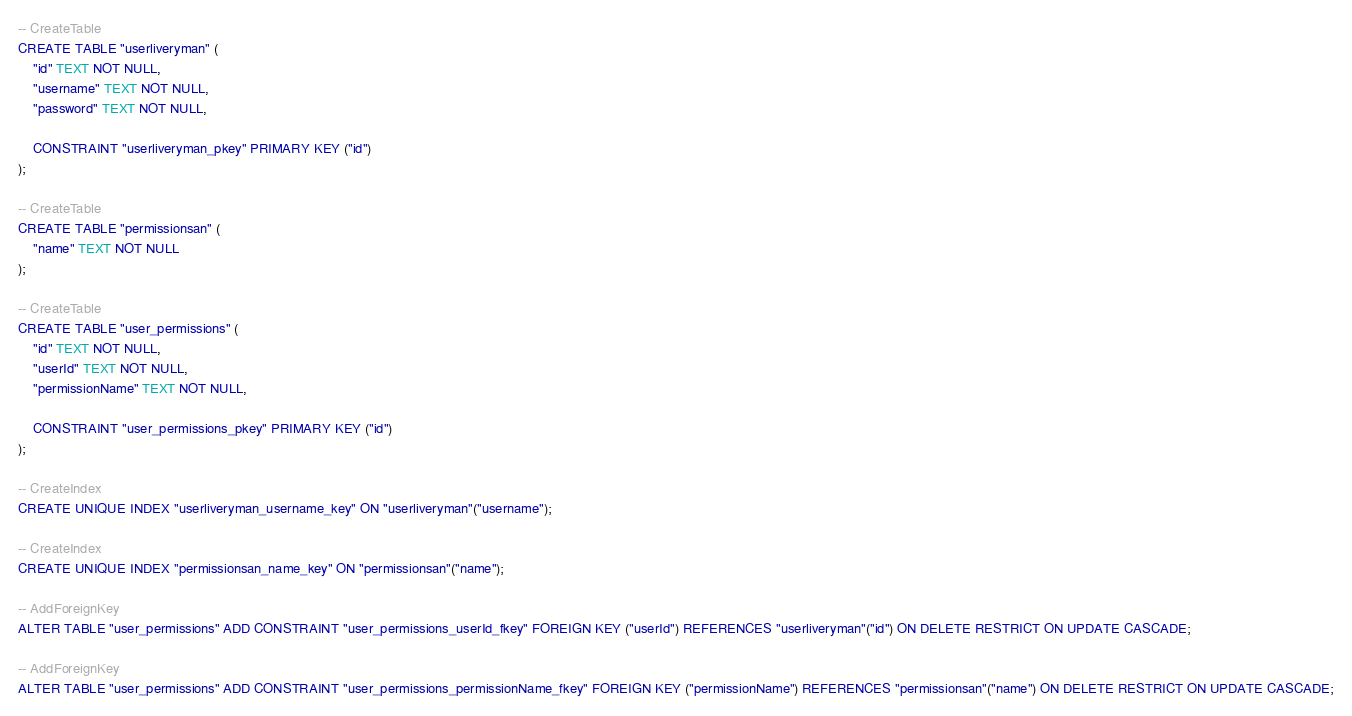Convert code to text. <code><loc_0><loc_0><loc_500><loc_500><_SQL_>-- CreateTable
CREATE TABLE "userliveryman" (
    "id" TEXT NOT NULL,
    "username" TEXT NOT NULL,
    "password" TEXT NOT NULL,

    CONSTRAINT "userliveryman_pkey" PRIMARY KEY ("id")
);

-- CreateTable
CREATE TABLE "permissionsan" (
    "name" TEXT NOT NULL
);

-- CreateTable
CREATE TABLE "user_permissions" (
    "id" TEXT NOT NULL,
    "userId" TEXT NOT NULL,
    "permissionName" TEXT NOT NULL,

    CONSTRAINT "user_permissions_pkey" PRIMARY KEY ("id")
);

-- CreateIndex
CREATE UNIQUE INDEX "userliveryman_username_key" ON "userliveryman"("username");

-- CreateIndex
CREATE UNIQUE INDEX "permissionsan_name_key" ON "permissionsan"("name");

-- AddForeignKey
ALTER TABLE "user_permissions" ADD CONSTRAINT "user_permissions_userId_fkey" FOREIGN KEY ("userId") REFERENCES "userliveryman"("id") ON DELETE RESTRICT ON UPDATE CASCADE;

-- AddForeignKey
ALTER TABLE "user_permissions" ADD CONSTRAINT "user_permissions_permissionName_fkey" FOREIGN KEY ("permissionName") REFERENCES "permissionsan"("name") ON DELETE RESTRICT ON UPDATE CASCADE;
</code> 